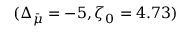<formula> <loc_0><loc_0><loc_500><loc_500>( \Delta _ { \bar { \mu } } = - 5 , \zeta _ { 0 } = 4 . 7 3 )</formula> 